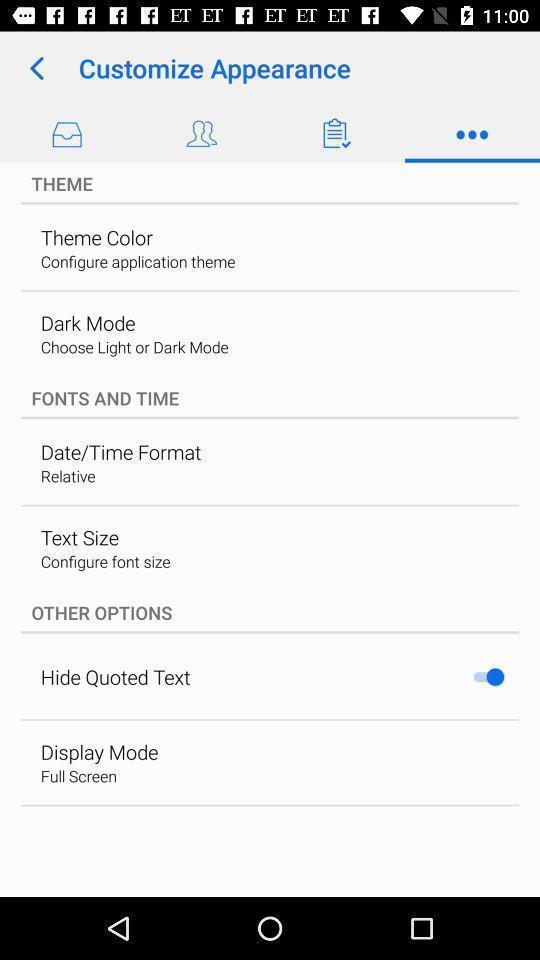Tell me what you see in this picture. Screen showing theme options. 